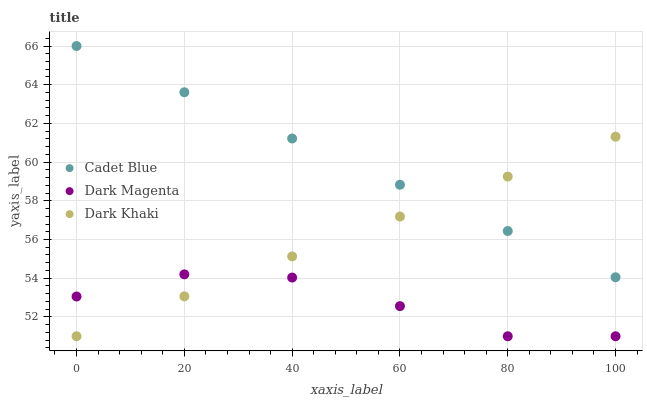Does Dark Magenta have the minimum area under the curve?
Answer yes or no. Yes. Does Cadet Blue have the maximum area under the curve?
Answer yes or no. Yes. Does Cadet Blue have the minimum area under the curve?
Answer yes or no. No. Does Dark Magenta have the maximum area under the curve?
Answer yes or no. No. Is Dark Khaki the smoothest?
Answer yes or no. Yes. Is Dark Magenta the roughest?
Answer yes or no. Yes. Is Dark Magenta the smoothest?
Answer yes or no. No. Is Cadet Blue the roughest?
Answer yes or no. No. Does Dark Khaki have the lowest value?
Answer yes or no. Yes. Does Cadet Blue have the lowest value?
Answer yes or no. No. Does Cadet Blue have the highest value?
Answer yes or no. Yes. Does Dark Magenta have the highest value?
Answer yes or no. No. Is Dark Magenta less than Cadet Blue?
Answer yes or no. Yes. Is Cadet Blue greater than Dark Magenta?
Answer yes or no. Yes. Does Dark Khaki intersect Dark Magenta?
Answer yes or no. Yes. Is Dark Khaki less than Dark Magenta?
Answer yes or no. No. Is Dark Khaki greater than Dark Magenta?
Answer yes or no. No. Does Dark Magenta intersect Cadet Blue?
Answer yes or no. No. 